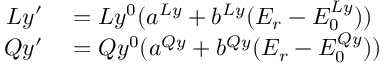Convert formula to latex. <formula><loc_0><loc_0><loc_500><loc_500>\begin{array} { r l } { L y ^ { \prime } } & = L y ^ { 0 } ( a ^ { L y } + b ^ { L y } ( E _ { r } - E _ { 0 } ^ { L y } ) ) } \\ { Q y ^ { \prime } } & = Q y ^ { 0 } ( a ^ { Q y } + b ^ { Q y } ( E _ { r } - E _ { 0 } ^ { Q y } ) ) } \end{array}</formula> 